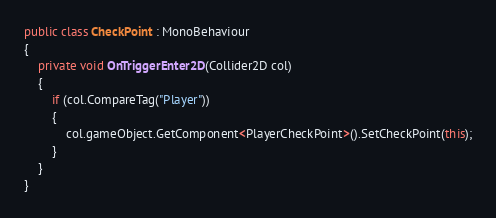Convert code to text. <code><loc_0><loc_0><loc_500><loc_500><_C#_>public class CheckPoint : MonoBehaviour
{
    private void OnTriggerEnter2D(Collider2D col)
    {
        if (col.CompareTag("Player"))
        {
            col.gameObject.GetComponent<PlayerCheckPoint>().SetCheckPoint(this);
        }
    }
}
</code> 